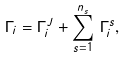<formula> <loc_0><loc_0><loc_500><loc_500>\Gamma _ { i } = \Gamma _ { i } ^ { J } + \sum _ { s = 1 } ^ { n _ { s } } \, \Gamma _ { i } ^ { s } ,</formula> 